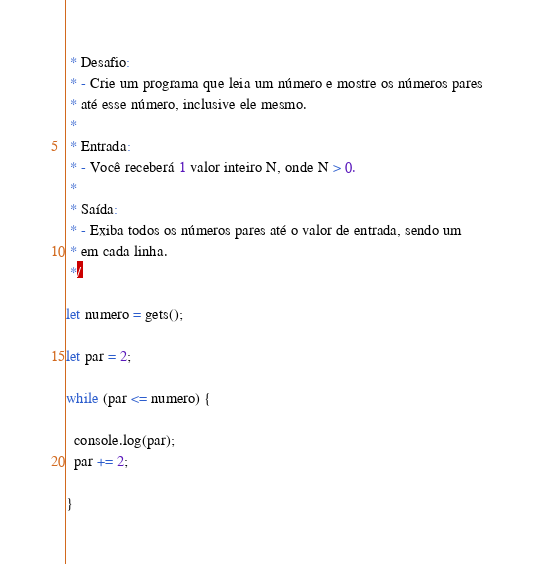Convert code to text. <code><loc_0><loc_0><loc_500><loc_500><_JavaScript_> * Desafio:
 * - Crie um programa que leia um número e mostre os números pares 
 * até esse número, inclusive ele mesmo.
 * 
 * Entrada:
 * - Você receberá 1 valor inteiro N, onde N > 0.
 * 
 * Saída:
 * - Exiba todos os números pares até o valor de entrada, sendo um 
 * em cada linha. 
 */

let numero = gets();

let par = 2;

while (par <= numero) {
  
  console.log(par);
  par += 2;

}</code> 